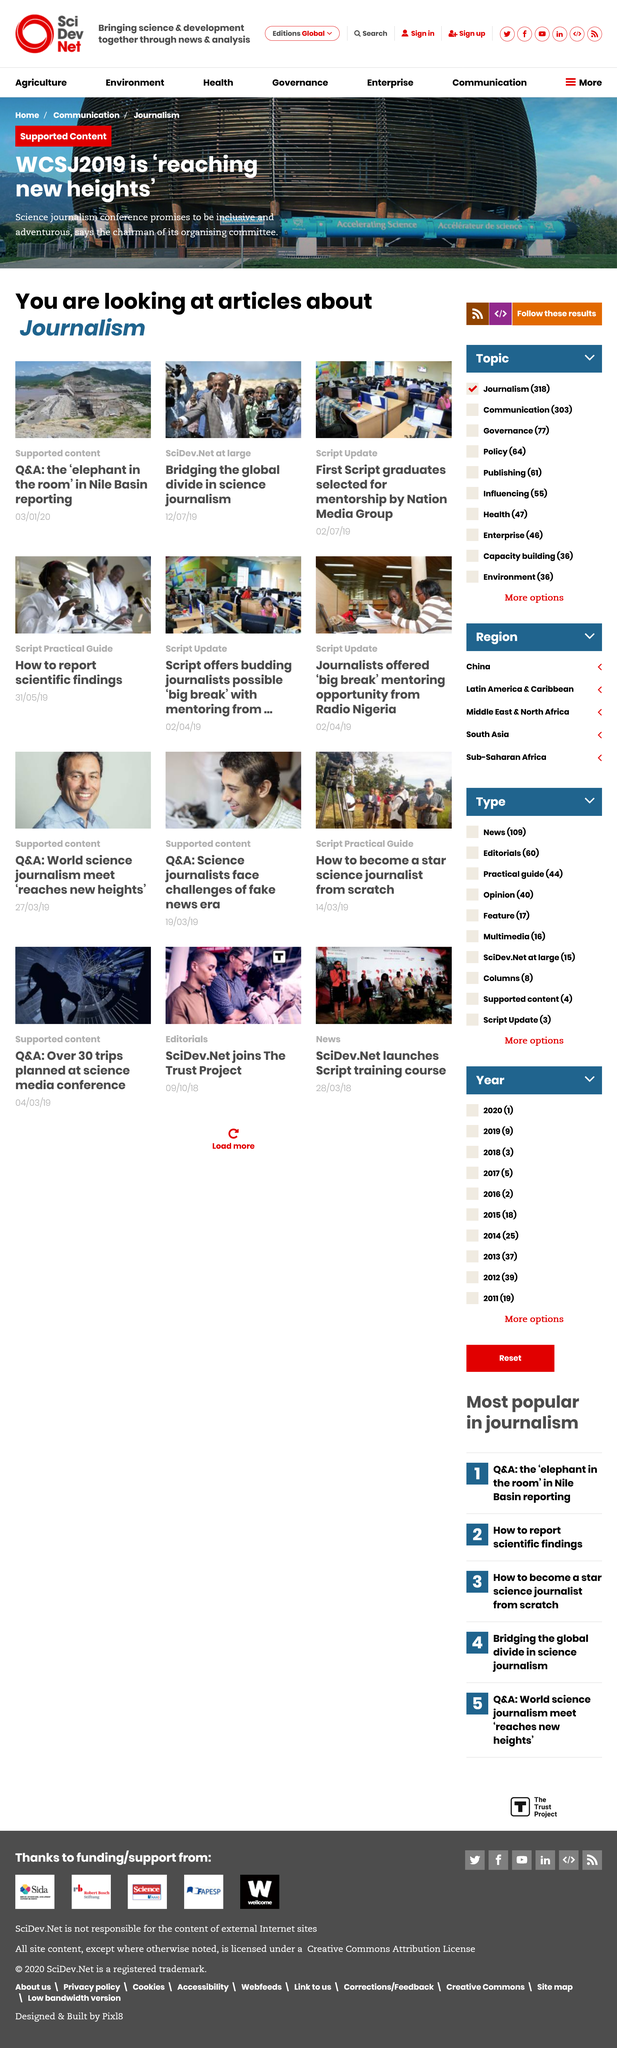Highlight a few significant elements in this photo. The article on the Q&A on Nile Basin reporting was published on January 3rd, 2023. WCSJ2019 is achieving great heights and breaking new records, it is an outstanding event that is reaching new levels of success. It is officially announced that the article on bridging the global divide in science journalism will be published on 12/07/19. 